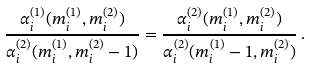<formula> <loc_0><loc_0><loc_500><loc_500>\frac { \alpha _ { i } ^ { ( 1 ) } ( m _ { i } ^ { ( 1 ) } , m _ { i } ^ { ( 2 ) } ) } { \alpha _ { i } ^ { ( 2 ) } ( m _ { i } ^ { ( 1 ) } , m _ { i } ^ { ( 2 ) } - 1 ) } = \frac { \alpha _ { i } ^ { ( 2 ) } ( m _ { i } ^ { ( 1 ) } , m _ { i } ^ { ( 2 ) } ) } { \alpha _ { i } ^ { ( 2 ) } ( m _ { i } ^ { ( 1 ) } - 1 , m _ { i } ^ { ( 2 ) } ) } \, .</formula> 